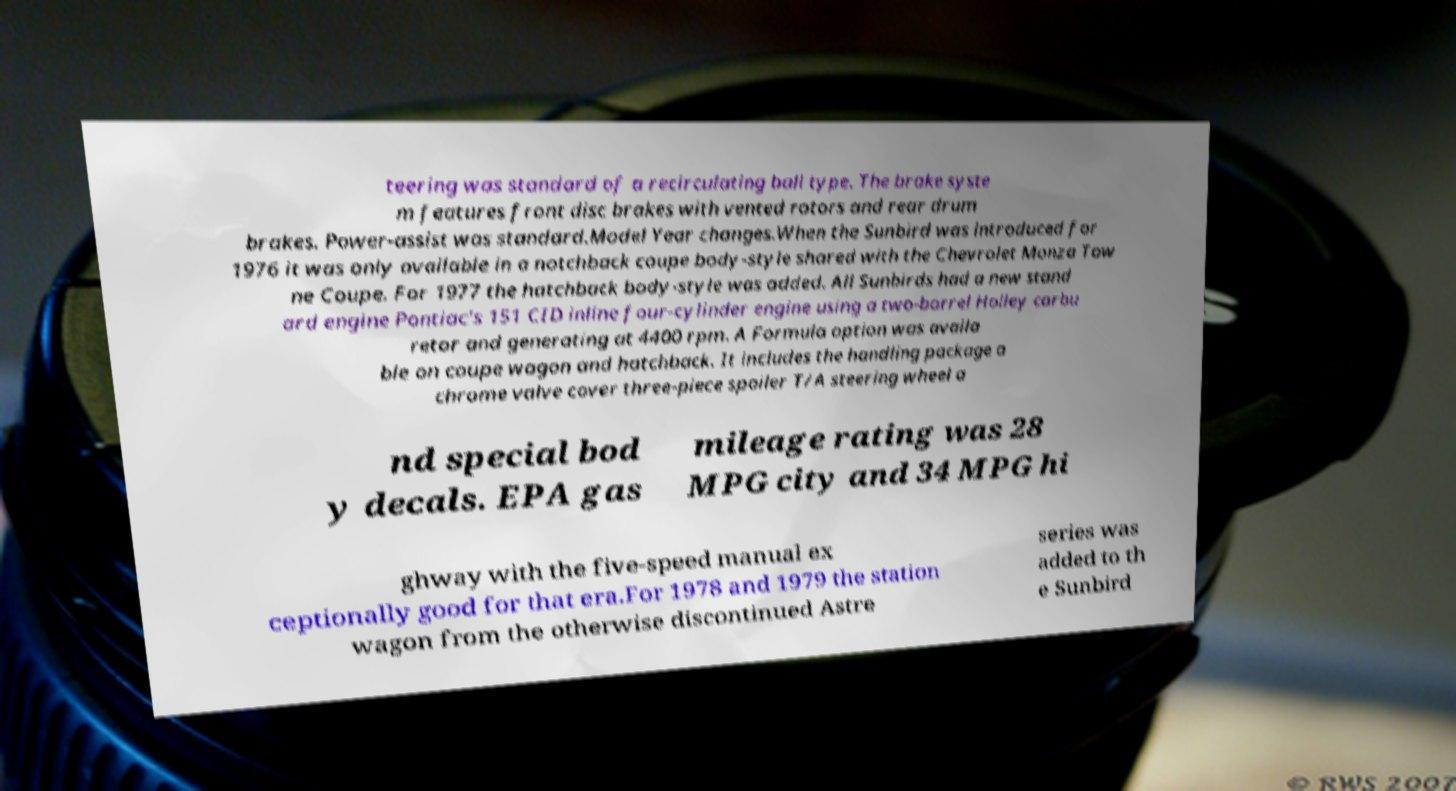Please identify and transcribe the text found in this image. teering was standard of a recirculating ball type. The brake syste m features front disc brakes with vented rotors and rear drum brakes. Power-assist was standard.Model Year changes.When the Sunbird was introduced for 1976 it was only available in a notchback coupe body-style shared with the Chevrolet Monza Tow ne Coupe. For 1977 the hatchback body-style was added. All Sunbirds had a new stand ard engine Pontiac's 151 CID inline four-cylinder engine using a two-barrel Holley carbu retor and generating at 4400 rpm. A Formula option was availa ble on coupe wagon and hatchback. It includes the handling package a chrome valve cover three-piece spoiler T/A steering wheel a nd special bod y decals. EPA gas mileage rating was 28 MPG city and 34 MPG hi ghway with the five-speed manual ex ceptionally good for that era.For 1978 and 1979 the station wagon from the otherwise discontinued Astre series was added to th e Sunbird 